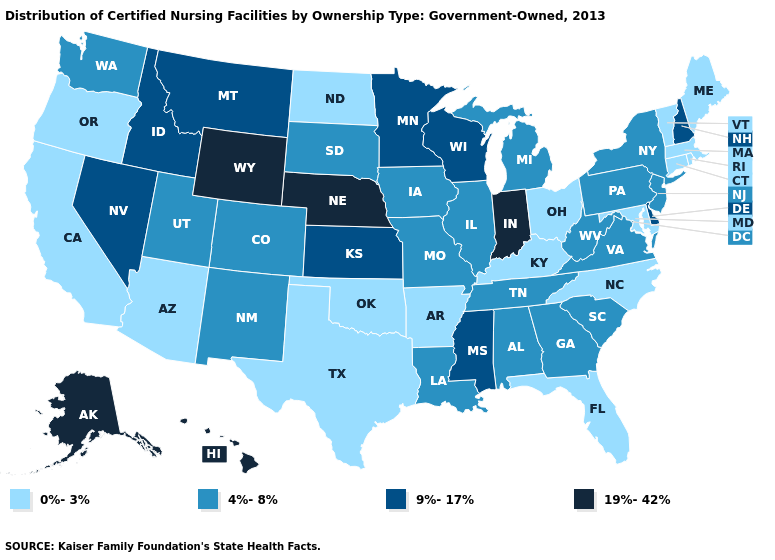Which states hav the highest value in the West?
Short answer required. Alaska, Hawaii, Wyoming. What is the value of Ohio?
Short answer required. 0%-3%. Name the states that have a value in the range 9%-17%?
Quick response, please. Delaware, Idaho, Kansas, Minnesota, Mississippi, Montana, Nevada, New Hampshire, Wisconsin. What is the value of South Carolina?
Write a very short answer. 4%-8%. Does the map have missing data?
Keep it brief. No. Which states have the lowest value in the South?
Quick response, please. Arkansas, Florida, Kentucky, Maryland, North Carolina, Oklahoma, Texas. Which states hav the highest value in the West?
Quick response, please. Alaska, Hawaii, Wyoming. How many symbols are there in the legend?
Write a very short answer. 4. Does Utah have the lowest value in the USA?
Keep it brief. No. What is the value of Illinois?
Be succinct. 4%-8%. Does New Mexico have the same value as Virginia?
Give a very brief answer. Yes. Does the map have missing data?
Concise answer only. No. Does Pennsylvania have the lowest value in the Northeast?
Keep it brief. No. Does the map have missing data?
Concise answer only. No. Is the legend a continuous bar?
Keep it brief. No. 